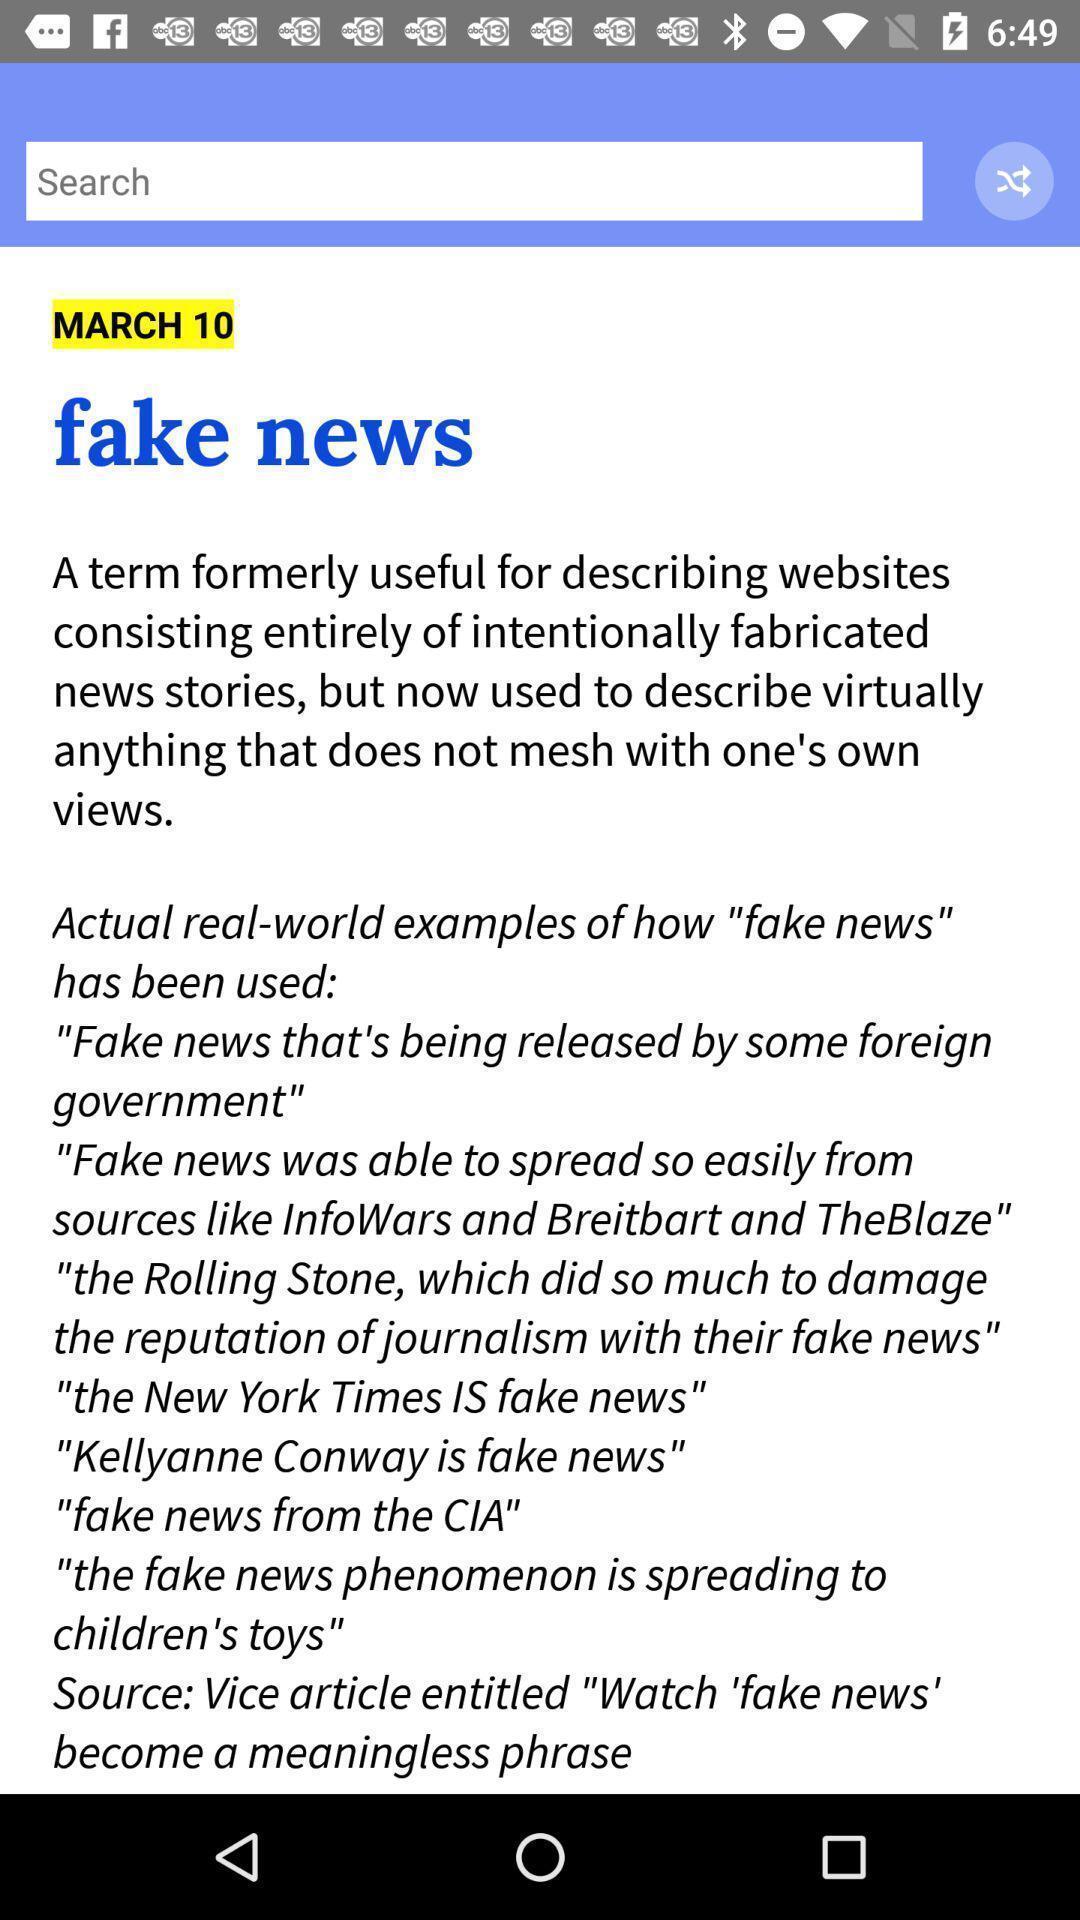Tell me about the visual elements in this screen capture. Search bar showing in this page. 